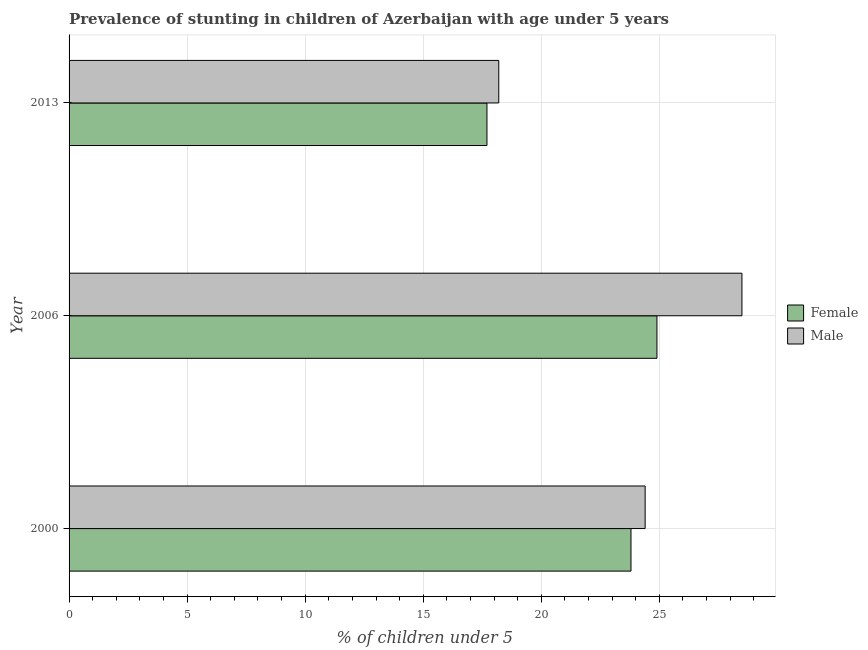How many different coloured bars are there?
Ensure brevity in your answer.  2. What is the label of the 2nd group of bars from the top?
Your response must be concise. 2006. In how many cases, is the number of bars for a given year not equal to the number of legend labels?
Your answer should be compact. 0. What is the percentage of stunted female children in 2000?
Offer a terse response. 23.8. Across all years, what is the maximum percentage of stunted female children?
Give a very brief answer. 24.9. Across all years, what is the minimum percentage of stunted female children?
Provide a short and direct response. 17.7. What is the total percentage of stunted female children in the graph?
Offer a very short reply. 66.4. What is the difference between the percentage of stunted male children in 2006 and the percentage of stunted female children in 2013?
Offer a terse response. 10.8. What is the average percentage of stunted male children per year?
Give a very brief answer. 23.7. In the year 2006, what is the difference between the percentage of stunted male children and percentage of stunted female children?
Offer a terse response. 3.6. What is the ratio of the percentage of stunted male children in 2006 to that in 2013?
Your response must be concise. 1.57. What is the difference between the highest and the lowest percentage of stunted male children?
Offer a terse response. 10.3. In how many years, is the percentage of stunted male children greater than the average percentage of stunted male children taken over all years?
Ensure brevity in your answer.  2. What does the 2nd bar from the top in 2013 represents?
Ensure brevity in your answer.  Female. What does the 1st bar from the bottom in 2006 represents?
Keep it short and to the point. Female. Are all the bars in the graph horizontal?
Offer a terse response. Yes. What is the difference between two consecutive major ticks on the X-axis?
Keep it short and to the point. 5. Does the graph contain any zero values?
Offer a terse response. No. Where does the legend appear in the graph?
Ensure brevity in your answer.  Center right. What is the title of the graph?
Ensure brevity in your answer.  Prevalence of stunting in children of Azerbaijan with age under 5 years. Does "Central government" appear as one of the legend labels in the graph?
Offer a terse response. No. What is the label or title of the X-axis?
Give a very brief answer.  % of children under 5. What is the  % of children under 5 of Female in 2000?
Provide a succinct answer. 23.8. What is the  % of children under 5 in Male in 2000?
Provide a succinct answer. 24.4. What is the  % of children under 5 of Female in 2006?
Offer a very short reply. 24.9. What is the  % of children under 5 of Female in 2013?
Ensure brevity in your answer.  17.7. What is the  % of children under 5 in Male in 2013?
Offer a very short reply. 18.2. Across all years, what is the maximum  % of children under 5 in Female?
Keep it short and to the point. 24.9. Across all years, what is the maximum  % of children under 5 in Male?
Offer a very short reply. 28.5. Across all years, what is the minimum  % of children under 5 of Female?
Give a very brief answer. 17.7. Across all years, what is the minimum  % of children under 5 of Male?
Your response must be concise. 18.2. What is the total  % of children under 5 in Female in the graph?
Your answer should be very brief. 66.4. What is the total  % of children under 5 in Male in the graph?
Ensure brevity in your answer.  71.1. What is the difference between the  % of children under 5 of Male in 2000 and that in 2013?
Offer a terse response. 6.2. What is the difference between the  % of children under 5 in Female in 2006 and that in 2013?
Your response must be concise. 7.2. What is the difference between the  % of children under 5 in Male in 2006 and that in 2013?
Provide a short and direct response. 10.3. What is the difference between the  % of children under 5 of Female in 2000 and the  % of children under 5 of Male in 2006?
Make the answer very short. -4.7. What is the difference between the  % of children under 5 of Female in 2000 and the  % of children under 5 of Male in 2013?
Your answer should be compact. 5.6. What is the difference between the  % of children under 5 in Female in 2006 and the  % of children under 5 in Male in 2013?
Give a very brief answer. 6.7. What is the average  % of children under 5 of Female per year?
Give a very brief answer. 22.13. What is the average  % of children under 5 of Male per year?
Make the answer very short. 23.7. In the year 2000, what is the difference between the  % of children under 5 in Female and  % of children under 5 in Male?
Keep it short and to the point. -0.6. In the year 2013, what is the difference between the  % of children under 5 in Female and  % of children under 5 in Male?
Offer a very short reply. -0.5. What is the ratio of the  % of children under 5 in Female in 2000 to that in 2006?
Ensure brevity in your answer.  0.96. What is the ratio of the  % of children under 5 in Male in 2000 to that in 2006?
Your answer should be compact. 0.86. What is the ratio of the  % of children under 5 in Female in 2000 to that in 2013?
Keep it short and to the point. 1.34. What is the ratio of the  % of children under 5 of Male in 2000 to that in 2013?
Offer a terse response. 1.34. What is the ratio of the  % of children under 5 in Female in 2006 to that in 2013?
Give a very brief answer. 1.41. What is the ratio of the  % of children under 5 in Male in 2006 to that in 2013?
Your answer should be very brief. 1.57. What is the difference between the highest and the second highest  % of children under 5 of Female?
Your response must be concise. 1.1. What is the difference between the highest and the lowest  % of children under 5 in Male?
Give a very brief answer. 10.3. 